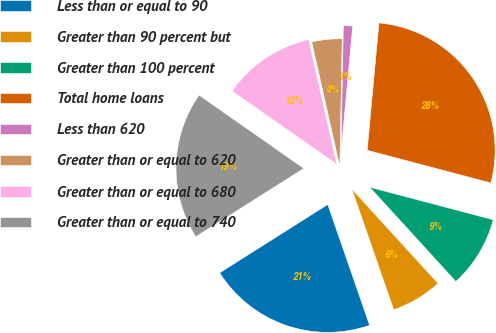<chart> <loc_0><loc_0><loc_500><loc_500><pie_chart><fcel>Less than or equal to 90<fcel>Greater than 90 percent but<fcel>Greater than 100 percent<fcel>Total home loans<fcel>Less than 620<fcel>Greater than or equal to 620<fcel>Greater than or equal to 680<fcel>Greater than or equal to 740<nl><fcel>21.33%<fcel>6.47%<fcel>9.11%<fcel>27.64%<fcel>1.17%<fcel>3.82%<fcel>11.76%<fcel>18.69%<nl></chart> 